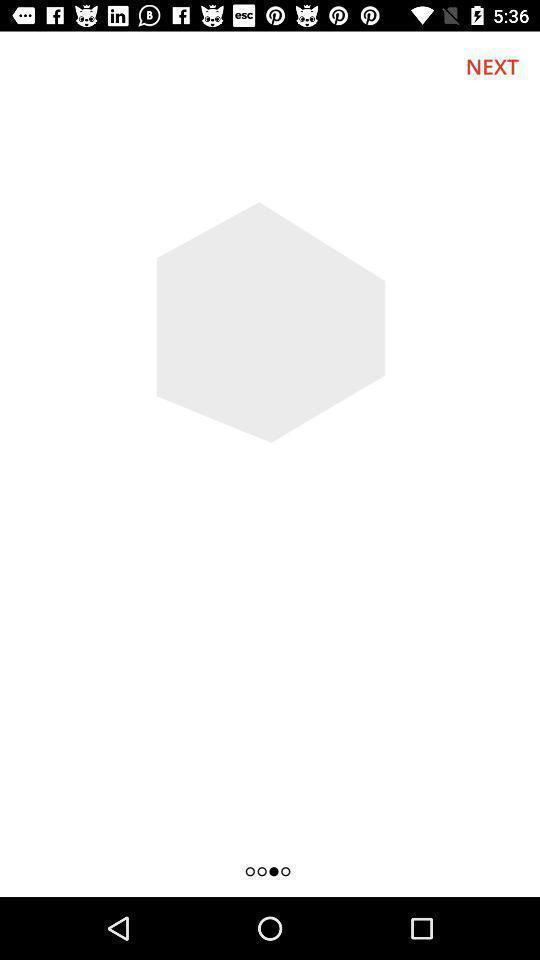Provide a detailed account of this screenshot. Screen shows next option. 